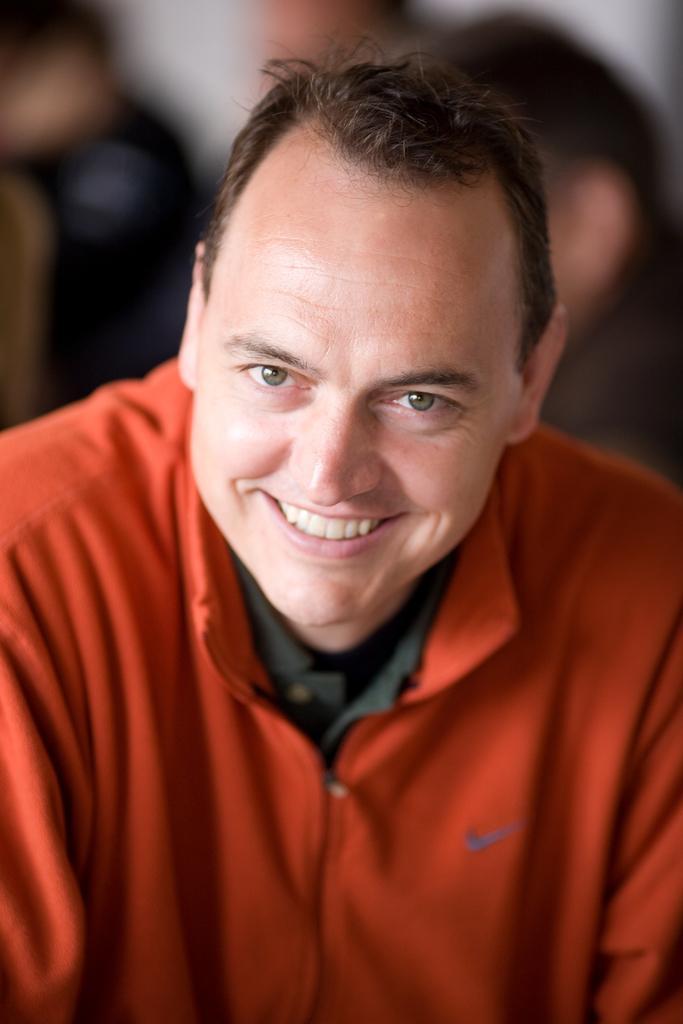In one or two sentences, can you explain what this image depicts? In this image there is a man standing wearing a red shirt, in the background it is blurred. 